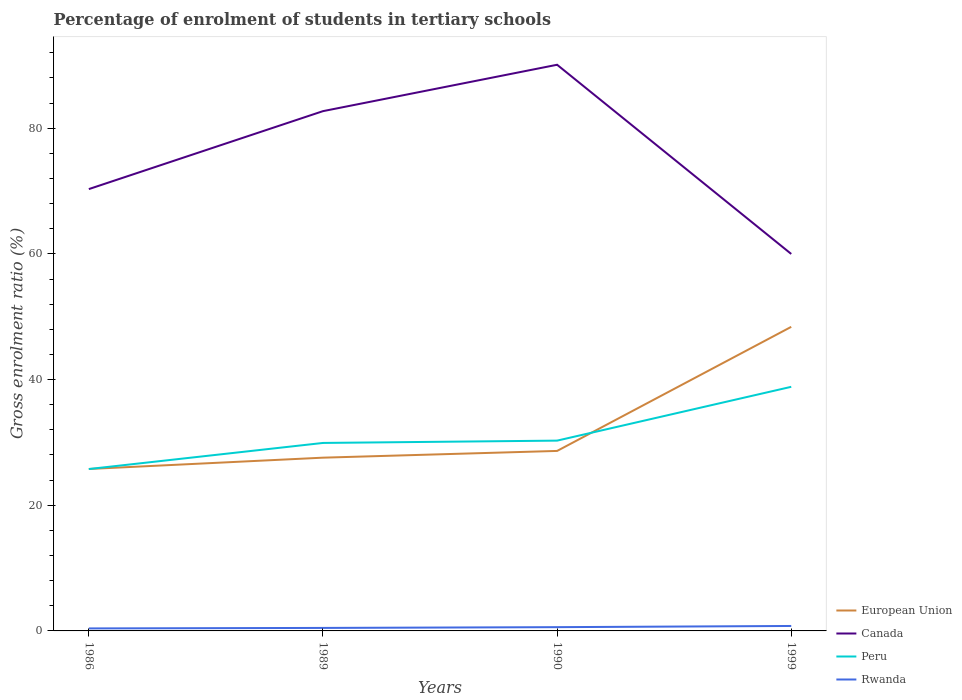Does the line corresponding to Canada intersect with the line corresponding to Rwanda?
Your answer should be very brief. No. Across all years, what is the maximum percentage of students enrolled in tertiary schools in Canada?
Your answer should be very brief. 59.99. In which year was the percentage of students enrolled in tertiary schools in Peru maximum?
Make the answer very short. 1986. What is the total percentage of students enrolled in tertiary schools in European Union in the graph?
Your answer should be compact. -19.75. What is the difference between the highest and the second highest percentage of students enrolled in tertiary schools in European Union?
Provide a short and direct response. 22.62. Does the graph contain any zero values?
Your answer should be very brief. No. Does the graph contain grids?
Your response must be concise. No. What is the title of the graph?
Provide a succinct answer. Percentage of enrolment of students in tertiary schools. What is the Gross enrolment ratio (%) of European Union in 1986?
Give a very brief answer. 25.77. What is the Gross enrolment ratio (%) of Canada in 1986?
Your answer should be compact. 70.31. What is the Gross enrolment ratio (%) in Peru in 1986?
Give a very brief answer. 25.76. What is the Gross enrolment ratio (%) in Rwanda in 1986?
Offer a terse response. 0.4. What is the Gross enrolment ratio (%) of European Union in 1989?
Offer a very short reply. 27.57. What is the Gross enrolment ratio (%) of Canada in 1989?
Keep it short and to the point. 82.71. What is the Gross enrolment ratio (%) of Peru in 1989?
Make the answer very short. 29.91. What is the Gross enrolment ratio (%) of Rwanda in 1989?
Ensure brevity in your answer.  0.48. What is the Gross enrolment ratio (%) of European Union in 1990?
Offer a very short reply. 28.64. What is the Gross enrolment ratio (%) of Canada in 1990?
Provide a succinct answer. 90.1. What is the Gross enrolment ratio (%) of Peru in 1990?
Make the answer very short. 30.28. What is the Gross enrolment ratio (%) in Rwanda in 1990?
Give a very brief answer. 0.6. What is the Gross enrolment ratio (%) in European Union in 1999?
Make the answer very short. 48.39. What is the Gross enrolment ratio (%) of Canada in 1999?
Your answer should be very brief. 59.99. What is the Gross enrolment ratio (%) in Peru in 1999?
Provide a succinct answer. 38.85. What is the Gross enrolment ratio (%) in Rwanda in 1999?
Offer a terse response. 0.79. Across all years, what is the maximum Gross enrolment ratio (%) of European Union?
Keep it short and to the point. 48.39. Across all years, what is the maximum Gross enrolment ratio (%) of Canada?
Make the answer very short. 90.1. Across all years, what is the maximum Gross enrolment ratio (%) in Peru?
Provide a succinct answer. 38.85. Across all years, what is the maximum Gross enrolment ratio (%) of Rwanda?
Ensure brevity in your answer.  0.79. Across all years, what is the minimum Gross enrolment ratio (%) of European Union?
Offer a very short reply. 25.77. Across all years, what is the minimum Gross enrolment ratio (%) of Canada?
Ensure brevity in your answer.  59.99. Across all years, what is the minimum Gross enrolment ratio (%) in Peru?
Offer a terse response. 25.76. Across all years, what is the minimum Gross enrolment ratio (%) of Rwanda?
Offer a very short reply. 0.4. What is the total Gross enrolment ratio (%) in European Union in the graph?
Keep it short and to the point. 130.37. What is the total Gross enrolment ratio (%) in Canada in the graph?
Ensure brevity in your answer.  303.11. What is the total Gross enrolment ratio (%) in Peru in the graph?
Your response must be concise. 124.8. What is the total Gross enrolment ratio (%) in Rwanda in the graph?
Make the answer very short. 2.26. What is the difference between the Gross enrolment ratio (%) of European Union in 1986 and that in 1989?
Your answer should be very brief. -1.8. What is the difference between the Gross enrolment ratio (%) in Canada in 1986 and that in 1989?
Provide a short and direct response. -12.4. What is the difference between the Gross enrolment ratio (%) in Peru in 1986 and that in 1989?
Your answer should be very brief. -4.15. What is the difference between the Gross enrolment ratio (%) in Rwanda in 1986 and that in 1989?
Provide a succinct answer. -0.08. What is the difference between the Gross enrolment ratio (%) in European Union in 1986 and that in 1990?
Keep it short and to the point. -2.87. What is the difference between the Gross enrolment ratio (%) of Canada in 1986 and that in 1990?
Offer a terse response. -19.79. What is the difference between the Gross enrolment ratio (%) in Peru in 1986 and that in 1990?
Your answer should be very brief. -4.52. What is the difference between the Gross enrolment ratio (%) in Rwanda in 1986 and that in 1990?
Provide a short and direct response. -0.2. What is the difference between the Gross enrolment ratio (%) in European Union in 1986 and that in 1999?
Your answer should be very brief. -22.62. What is the difference between the Gross enrolment ratio (%) in Canada in 1986 and that in 1999?
Your answer should be very brief. 10.32. What is the difference between the Gross enrolment ratio (%) of Peru in 1986 and that in 1999?
Offer a very short reply. -13.08. What is the difference between the Gross enrolment ratio (%) of Rwanda in 1986 and that in 1999?
Your answer should be compact. -0.39. What is the difference between the Gross enrolment ratio (%) of European Union in 1989 and that in 1990?
Offer a terse response. -1.07. What is the difference between the Gross enrolment ratio (%) of Canada in 1989 and that in 1990?
Your answer should be very brief. -7.38. What is the difference between the Gross enrolment ratio (%) in Peru in 1989 and that in 1990?
Offer a very short reply. -0.37. What is the difference between the Gross enrolment ratio (%) in Rwanda in 1989 and that in 1990?
Make the answer very short. -0.12. What is the difference between the Gross enrolment ratio (%) in European Union in 1989 and that in 1999?
Ensure brevity in your answer.  -20.82. What is the difference between the Gross enrolment ratio (%) of Canada in 1989 and that in 1999?
Keep it short and to the point. 22.73. What is the difference between the Gross enrolment ratio (%) of Peru in 1989 and that in 1999?
Provide a short and direct response. -8.93. What is the difference between the Gross enrolment ratio (%) of Rwanda in 1989 and that in 1999?
Offer a terse response. -0.31. What is the difference between the Gross enrolment ratio (%) of European Union in 1990 and that in 1999?
Ensure brevity in your answer.  -19.75. What is the difference between the Gross enrolment ratio (%) in Canada in 1990 and that in 1999?
Keep it short and to the point. 30.11. What is the difference between the Gross enrolment ratio (%) in Peru in 1990 and that in 1999?
Your answer should be very brief. -8.56. What is the difference between the Gross enrolment ratio (%) of Rwanda in 1990 and that in 1999?
Your answer should be very brief. -0.19. What is the difference between the Gross enrolment ratio (%) of European Union in 1986 and the Gross enrolment ratio (%) of Canada in 1989?
Offer a very short reply. -56.95. What is the difference between the Gross enrolment ratio (%) in European Union in 1986 and the Gross enrolment ratio (%) in Peru in 1989?
Give a very brief answer. -4.15. What is the difference between the Gross enrolment ratio (%) of European Union in 1986 and the Gross enrolment ratio (%) of Rwanda in 1989?
Ensure brevity in your answer.  25.29. What is the difference between the Gross enrolment ratio (%) in Canada in 1986 and the Gross enrolment ratio (%) in Peru in 1989?
Keep it short and to the point. 40.4. What is the difference between the Gross enrolment ratio (%) in Canada in 1986 and the Gross enrolment ratio (%) in Rwanda in 1989?
Offer a very short reply. 69.83. What is the difference between the Gross enrolment ratio (%) of Peru in 1986 and the Gross enrolment ratio (%) of Rwanda in 1989?
Offer a very short reply. 25.28. What is the difference between the Gross enrolment ratio (%) of European Union in 1986 and the Gross enrolment ratio (%) of Canada in 1990?
Your answer should be very brief. -64.33. What is the difference between the Gross enrolment ratio (%) in European Union in 1986 and the Gross enrolment ratio (%) in Peru in 1990?
Provide a short and direct response. -4.51. What is the difference between the Gross enrolment ratio (%) in European Union in 1986 and the Gross enrolment ratio (%) in Rwanda in 1990?
Your response must be concise. 25.17. What is the difference between the Gross enrolment ratio (%) of Canada in 1986 and the Gross enrolment ratio (%) of Peru in 1990?
Keep it short and to the point. 40.03. What is the difference between the Gross enrolment ratio (%) of Canada in 1986 and the Gross enrolment ratio (%) of Rwanda in 1990?
Ensure brevity in your answer.  69.71. What is the difference between the Gross enrolment ratio (%) in Peru in 1986 and the Gross enrolment ratio (%) in Rwanda in 1990?
Offer a very short reply. 25.16. What is the difference between the Gross enrolment ratio (%) of European Union in 1986 and the Gross enrolment ratio (%) of Canada in 1999?
Give a very brief answer. -34.22. What is the difference between the Gross enrolment ratio (%) of European Union in 1986 and the Gross enrolment ratio (%) of Peru in 1999?
Your response must be concise. -13.08. What is the difference between the Gross enrolment ratio (%) in European Union in 1986 and the Gross enrolment ratio (%) in Rwanda in 1999?
Give a very brief answer. 24.98. What is the difference between the Gross enrolment ratio (%) of Canada in 1986 and the Gross enrolment ratio (%) of Peru in 1999?
Provide a short and direct response. 31.46. What is the difference between the Gross enrolment ratio (%) of Canada in 1986 and the Gross enrolment ratio (%) of Rwanda in 1999?
Your response must be concise. 69.52. What is the difference between the Gross enrolment ratio (%) in Peru in 1986 and the Gross enrolment ratio (%) in Rwanda in 1999?
Offer a terse response. 24.97. What is the difference between the Gross enrolment ratio (%) in European Union in 1989 and the Gross enrolment ratio (%) in Canada in 1990?
Offer a terse response. -62.53. What is the difference between the Gross enrolment ratio (%) in European Union in 1989 and the Gross enrolment ratio (%) in Peru in 1990?
Make the answer very short. -2.71. What is the difference between the Gross enrolment ratio (%) of European Union in 1989 and the Gross enrolment ratio (%) of Rwanda in 1990?
Your response must be concise. 26.97. What is the difference between the Gross enrolment ratio (%) of Canada in 1989 and the Gross enrolment ratio (%) of Peru in 1990?
Keep it short and to the point. 52.43. What is the difference between the Gross enrolment ratio (%) in Canada in 1989 and the Gross enrolment ratio (%) in Rwanda in 1990?
Ensure brevity in your answer.  82.12. What is the difference between the Gross enrolment ratio (%) of Peru in 1989 and the Gross enrolment ratio (%) of Rwanda in 1990?
Provide a succinct answer. 29.32. What is the difference between the Gross enrolment ratio (%) in European Union in 1989 and the Gross enrolment ratio (%) in Canada in 1999?
Provide a succinct answer. -32.42. What is the difference between the Gross enrolment ratio (%) of European Union in 1989 and the Gross enrolment ratio (%) of Peru in 1999?
Give a very brief answer. -11.28. What is the difference between the Gross enrolment ratio (%) of European Union in 1989 and the Gross enrolment ratio (%) of Rwanda in 1999?
Provide a short and direct response. 26.78. What is the difference between the Gross enrolment ratio (%) of Canada in 1989 and the Gross enrolment ratio (%) of Peru in 1999?
Offer a very short reply. 43.87. What is the difference between the Gross enrolment ratio (%) of Canada in 1989 and the Gross enrolment ratio (%) of Rwanda in 1999?
Provide a short and direct response. 81.93. What is the difference between the Gross enrolment ratio (%) in Peru in 1989 and the Gross enrolment ratio (%) in Rwanda in 1999?
Keep it short and to the point. 29.13. What is the difference between the Gross enrolment ratio (%) of European Union in 1990 and the Gross enrolment ratio (%) of Canada in 1999?
Keep it short and to the point. -31.35. What is the difference between the Gross enrolment ratio (%) of European Union in 1990 and the Gross enrolment ratio (%) of Peru in 1999?
Your answer should be very brief. -10.2. What is the difference between the Gross enrolment ratio (%) of European Union in 1990 and the Gross enrolment ratio (%) of Rwanda in 1999?
Provide a succinct answer. 27.85. What is the difference between the Gross enrolment ratio (%) of Canada in 1990 and the Gross enrolment ratio (%) of Peru in 1999?
Give a very brief answer. 51.25. What is the difference between the Gross enrolment ratio (%) in Canada in 1990 and the Gross enrolment ratio (%) in Rwanda in 1999?
Provide a short and direct response. 89.31. What is the difference between the Gross enrolment ratio (%) of Peru in 1990 and the Gross enrolment ratio (%) of Rwanda in 1999?
Make the answer very short. 29.49. What is the average Gross enrolment ratio (%) of European Union per year?
Make the answer very short. 32.59. What is the average Gross enrolment ratio (%) of Canada per year?
Your answer should be compact. 75.78. What is the average Gross enrolment ratio (%) in Peru per year?
Make the answer very short. 31.2. What is the average Gross enrolment ratio (%) in Rwanda per year?
Ensure brevity in your answer.  0.57. In the year 1986, what is the difference between the Gross enrolment ratio (%) in European Union and Gross enrolment ratio (%) in Canada?
Your response must be concise. -44.54. In the year 1986, what is the difference between the Gross enrolment ratio (%) of European Union and Gross enrolment ratio (%) of Peru?
Give a very brief answer. 0.01. In the year 1986, what is the difference between the Gross enrolment ratio (%) of European Union and Gross enrolment ratio (%) of Rwanda?
Offer a terse response. 25.37. In the year 1986, what is the difference between the Gross enrolment ratio (%) of Canada and Gross enrolment ratio (%) of Peru?
Provide a short and direct response. 44.55. In the year 1986, what is the difference between the Gross enrolment ratio (%) in Canada and Gross enrolment ratio (%) in Rwanda?
Your answer should be very brief. 69.91. In the year 1986, what is the difference between the Gross enrolment ratio (%) in Peru and Gross enrolment ratio (%) in Rwanda?
Offer a very short reply. 25.37. In the year 1989, what is the difference between the Gross enrolment ratio (%) in European Union and Gross enrolment ratio (%) in Canada?
Make the answer very short. -55.14. In the year 1989, what is the difference between the Gross enrolment ratio (%) in European Union and Gross enrolment ratio (%) in Peru?
Give a very brief answer. -2.34. In the year 1989, what is the difference between the Gross enrolment ratio (%) of European Union and Gross enrolment ratio (%) of Rwanda?
Your answer should be very brief. 27.09. In the year 1989, what is the difference between the Gross enrolment ratio (%) of Canada and Gross enrolment ratio (%) of Peru?
Keep it short and to the point. 52.8. In the year 1989, what is the difference between the Gross enrolment ratio (%) of Canada and Gross enrolment ratio (%) of Rwanda?
Offer a very short reply. 82.24. In the year 1989, what is the difference between the Gross enrolment ratio (%) of Peru and Gross enrolment ratio (%) of Rwanda?
Make the answer very short. 29.44. In the year 1990, what is the difference between the Gross enrolment ratio (%) of European Union and Gross enrolment ratio (%) of Canada?
Provide a succinct answer. -61.45. In the year 1990, what is the difference between the Gross enrolment ratio (%) in European Union and Gross enrolment ratio (%) in Peru?
Your answer should be very brief. -1.64. In the year 1990, what is the difference between the Gross enrolment ratio (%) of European Union and Gross enrolment ratio (%) of Rwanda?
Make the answer very short. 28.05. In the year 1990, what is the difference between the Gross enrolment ratio (%) of Canada and Gross enrolment ratio (%) of Peru?
Keep it short and to the point. 59.82. In the year 1990, what is the difference between the Gross enrolment ratio (%) of Canada and Gross enrolment ratio (%) of Rwanda?
Provide a succinct answer. 89.5. In the year 1990, what is the difference between the Gross enrolment ratio (%) of Peru and Gross enrolment ratio (%) of Rwanda?
Provide a succinct answer. 29.68. In the year 1999, what is the difference between the Gross enrolment ratio (%) in European Union and Gross enrolment ratio (%) in Canada?
Ensure brevity in your answer.  -11.6. In the year 1999, what is the difference between the Gross enrolment ratio (%) in European Union and Gross enrolment ratio (%) in Peru?
Your answer should be very brief. 9.54. In the year 1999, what is the difference between the Gross enrolment ratio (%) in European Union and Gross enrolment ratio (%) in Rwanda?
Offer a very short reply. 47.6. In the year 1999, what is the difference between the Gross enrolment ratio (%) of Canada and Gross enrolment ratio (%) of Peru?
Your answer should be compact. 21.14. In the year 1999, what is the difference between the Gross enrolment ratio (%) of Canada and Gross enrolment ratio (%) of Rwanda?
Provide a succinct answer. 59.2. In the year 1999, what is the difference between the Gross enrolment ratio (%) of Peru and Gross enrolment ratio (%) of Rwanda?
Provide a succinct answer. 38.06. What is the ratio of the Gross enrolment ratio (%) of European Union in 1986 to that in 1989?
Provide a succinct answer. 0.93. What is the ratio of the Gross enrolment ratio (%) of Canada in 1986 to that in 1989?
Offer a very short reply. 0.85. What is the ratio of the Gross enrolment ratio (%) in Peru in 1986 to that in 1989?
Your response must be concise. 0.86. What is the ratio of the Gross enrolment ratio (%) in Rwanda in 1986 to that in 1989?
Make the answer very short. 0.83. What is the ratio of the Gross enrolment ratio (%) in European Union in 1986 to that in 1990?
Give a very brief answer. 0.9. What is the ratio of the Gross enrolment ratio (%) of Canada in 1986 to that in 1990?
Your answer should be compact. 0.78. What is the ratio of the Gross enrolment ratio (%) of Peru in 1986 to that in 1990?
Offer a very short reply. 0.85. What is the ratio of the Gross enrolment ratio (%) in Rwanda in 1986 to that in 1990?
Give a very brief answer. 0.66. What is the ratio of the Gross enrolment ratio (%) in European Union in 1986 to that in 1999?
Give a very brief answer. 0.53. What is the ratio of the Gross enrolment ratio (%) of Canada in 1986 to that in 1999?
Your answer should be compact. 1.17. What is the ratio of the Gross enrolment ratio (%) of Peru in 1986 to that in 1999?
Your answer should be very brief. 0.66. What is the ratio of the Gross enrolment ratio (%) of Rwanda in 1986 to that in 1999?
Make the answer very short. 0.5. What is the ratio of the Gross enrolment ratio (%) in European Union in 1989 to that in 1990?
Keep it short and to the point. 0.96. What is the ratio of the Gross enrolment ratio (%) of Canada in 1989 to that in 1990?
Your response must be concise. 0.92. What is the ratio of the Gross enrolment ratio (%) in Rwanda in 1989 to that in 1990?
Your answer should be compact. 0.8. What is the ratio of the Gross enrolment ratio (%) of European Union in 1989 to that in 1999?
Provide a short and direct response. 0.57. What is the ratio of the Gross enrolment ratio (%) in Canada in 1989 to that in 1999?
Offer a very short reply. 1.38. What is the ratio of the Gross enrolment ratio (%) in Peru in 1989 to that in 1999?
Give a very brief answer. 0.77. What is the ratio of the Gross enrolment ratio (%) of Rwanda in 1989 to that in 1999?
Make the answer very short. 0.61. What is the ratio of the Gross enrolment ratio (%) of European Union in 1990 to that in 1999?
Your response must be concise. 0.59. What is the ratio of the Gross enrolment ratio (%) of Canada in 1990 to that in 1999?
Keep it short and to the point. 1.5. What is the ratio of the Gross enrolment ratio (%) of Peru in 1990 to that in 1999?
Your answer should be compact. 0.78. What is the ratio of the Gross enrolment ratio (%) in Rwanda in 1990 to that in 1999?
Provide a succinct answer. 0.76. What is the difference between the highest and the second highest Gross enrolment ratio (%) in European Union?
Ensure brevity in your answer.  19.75. What is the difference between the highest and the second highest Gross enrolment ratio (%) in Canada?
Provide a succinct answer. 7.38. What is the difference between the highest and the second highest Gross enrolment ratio (%) of Peru?
Your answer should be compact. 8.56. What is the difference between the highest and the second highest Gross enrolment ratio (%) of Rwanda?
Provide a short and direct response. 0.19. What is the difference between the highest and the lowest Gross enrolment ratio (%) in European Union?
Your response must be concise. 22.62. What is the difference between the highest and the lowest Gross enrolment ratio (%) of Canada?
Give a very brief answer. 30.11. What is the difference between the highest and the lowest Gross enrolment ratio (%) in Peru?
Keep it short and to the point. 13.08. What is the difference between the highest and the lowest Gross enrolment ratio (%) in Rwanda?
Provide a succinct answer. 0.39. 